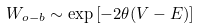Convert formula to latex. <formula><loc_0><loc_0><loc_500><loc_500>W _ { o - b } \sim \exp \left [ - 2 \theta ( V - E ) \right ]</formula> 